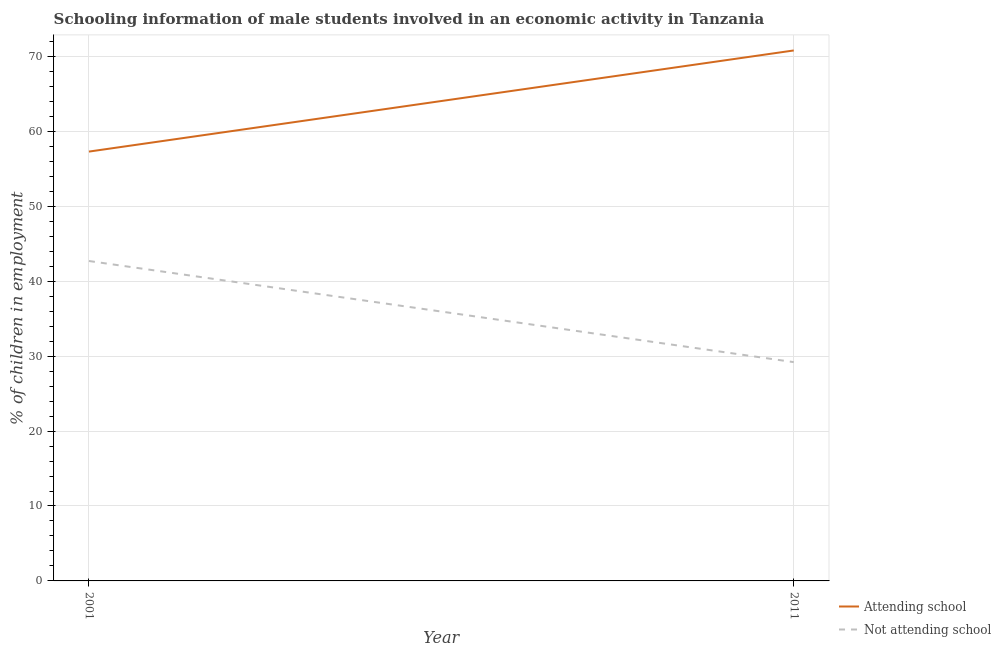Does the line corresponding to percentage of employed males who are attending school intersect with the line corresponding to percentage of employed males who are not attending school?
Give a very brief answer. No. What is the percentage of employed males who are not attending school in 2001?
Provide a short and direct response. 42.7. Across all years, what is the maximum percentage of employed males who are attending school?
Your response must be concise. 70.8. Across all years, what is the minimum percentage of employed males who are attending school?
Offer a very short reply. 57.3. In which year was the percentage of employed males who are attending school maximum?
Your response must be concise. 2011. What is the total percentage of employed males who are attending school in the graph?
Your response must be concise. 128.1. What is the difference between the percentage of employed males who are attending school in 2001 and that in 2011?
Your answer should be compact. -13.5. What is the difference between the percentage of employed males who are attending school in 2011 and the percentage of employed males who are not attending school in 2001?
Offer a terse response. 28.1. What is the average percentage of employed males who are attending school per year?
Your answer should be very brief. 64.05. In the year 2011, what is the difference between the percentage of employed males who are not attending school and percentage of employed males who are attending school?
Offer a very short reply. -41.6. In how many years, is the percentage of employed males who are attending school greater than 62 %?
Give a very brief answer. 1. What is the ratio of the percentage of employed males who are not attending school in 2001 to that in 2011?
Offer a terse response. 1.46. Is the percentage of employed males who are attending school in 2001 less than that in 2011?
Keep it short and to the point. Yes. Is the percentage of employed males who are not attending school strictly greater than the percentage of employed males who are attending school over the years?
Ensure brevity in your answer.  No. Is the percentage of employed males who are attending school strictly less than the percentage of employed males who are not attending school over the years?
Ensure brevity in your answer.  No. How many lines are there?
Give a very brief answer. 2. Does the graph contain any zero values?
Give a very brief answer. No. Does the graph contain grids?
Give a very brief answer. Yes. What is the title of the graph?
Provide a short and direct response. Schooling information of male students involved in an economic activity in Tanzania. Does "Male labor force" appear as one of the legend labels in the graph?
Provide a short and direct response. No. What is the label or title of the Y-axis?
Ensure brevity in your answer.  % of children in employment. What is the % of children in employment of Attending school in 2001?
Ensure brevity in your answer.  57.3. What is the % of children in employment in Not attending school in 2001?
Make the answer very short. 42.7. What is the % of children in employment in Attending school in 2011?
Offer a very short reply. 70.8. What is the % of children in employment of Not attending school in 2011?
Your answer should be very brief. 29.2. Across all years, what is the maximum % of children in employment of Attending school?
Your answer should be very brief. 70.8. Across all years, what is the maximum % of children in employment in Not attending school?
Offer a terse response. 42.7. Across all years, what is the minimum % of children in employment of Attending school?
Keep it short and to the point. 57.3. Across all years, what is the minimum % of children in employment in Not attending school?
Offer a terse response. 29.2. What is the total % of children in employment in Attending school in the graph?
Your answer should be compact. 128.1. What is the total % of children in employment in Not attending school in the graph?
Provide a succinct answer. 71.9. What is the difference between the % of children in employment of Attending school in 2001 and that in 2011?
Provide a succinct answer. -13.5. What is the difference between the % of children in employment in Not attending school in 2001 and that in 2011?
Make the answer very short. 13.5. What is the difference between the % of children in employment in Attending school in 2001 and the % of children in employment in Not attending school in 2011?
Your response must be concise. 28.1. What is the average % of children in employment in Attending school per year?
Your answer should be compact. 64.05. What is the average % of children in employment of Not attending school per year?
Your answer should be very brief. 35.95. In the year 2001, what is the difference between the % of children in employment in Attending school and % of children in employment in Not attending school?
Keep it short and to the point. 14.6. In the year 2011, what is the difference between the % of children in employment of Attending school and % of children in employment of Not attending school?
Your answer should be very brief. 41.6. What is the ratio of the % of children in employment of Attending school in 2001 to that in 2011?
Provide a succinct answer. 0.81. What is the ratio of the % of children in employment in Not attending school in 2001 to that in 2011?
Offer a very short reply. 1.46. What is the difference between the highest and the second highest % of children in employment in Attending school?
Offer a terse response. 13.5. What is the difference between the highest and the second highest % of children in employment of Not attending school?
Offer a very short reply. 13.5. What is the difference between the highest and the lowest % of children in employment in Attending school?
Provide a short and direct response. 13.5. What is the difference between the highest and the lowest % of children in employment of Not attending school?
Your response must be concise. 13.5. 